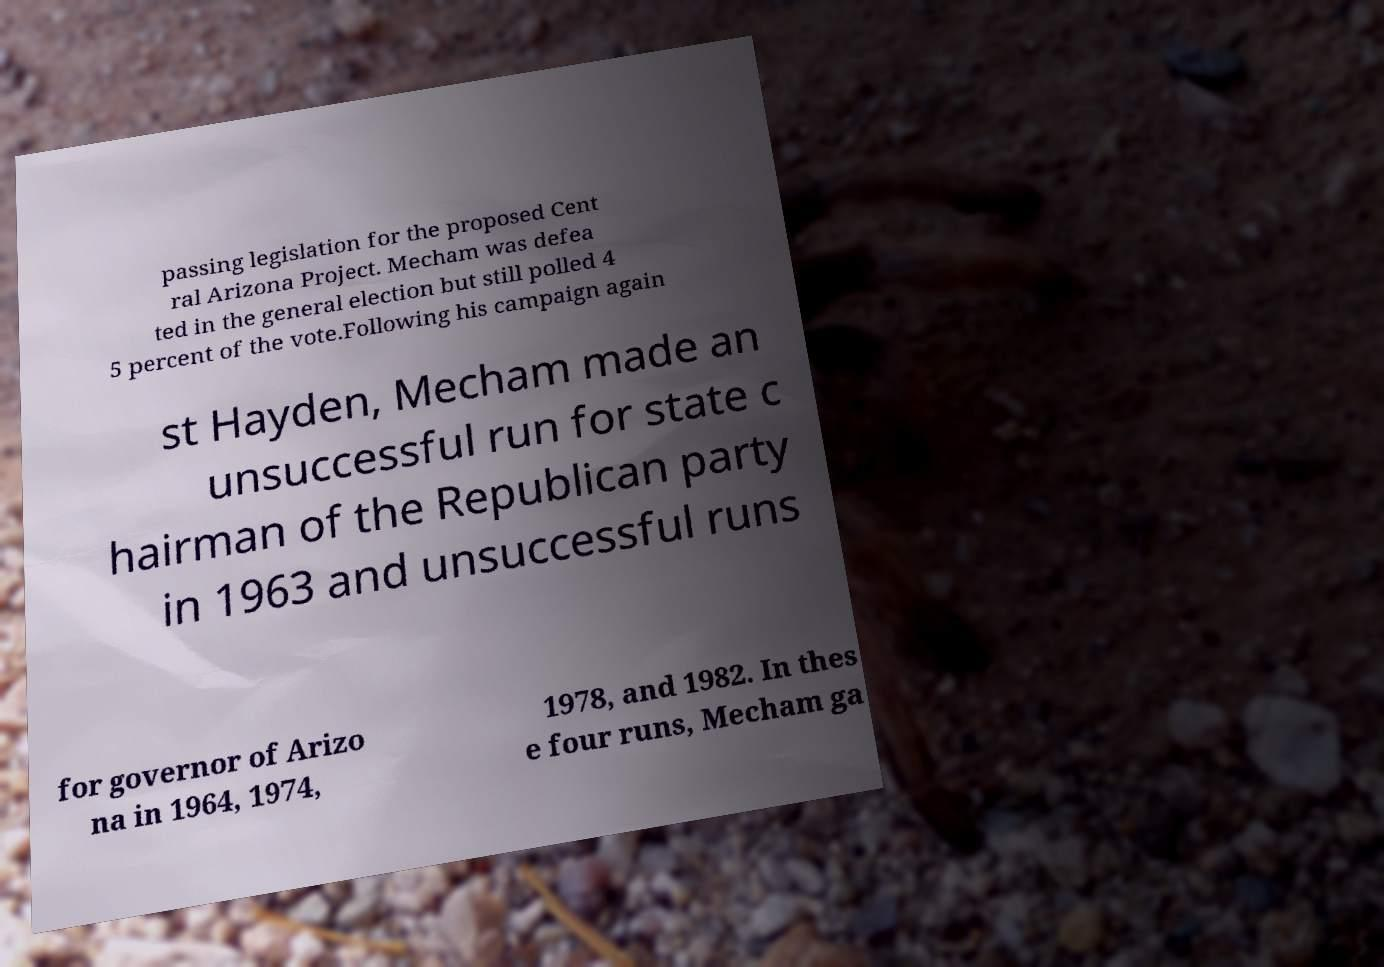What messages or text are displayed in this image? I need them in a readable, typed format. passing legislation for the proposed Cent ral Arizona Project. Mecham was defea ted in the general election but still polled 4 5 percent of the vote.Following his campaign again st Hayden, Mecham made an unsuccessful run for state c hairman of the Republican party in 1963 and unsuccessful runs for governor of Arizo na in 1964, 1974, 1978, and 1982. In thes e four runs, Mecham ga 